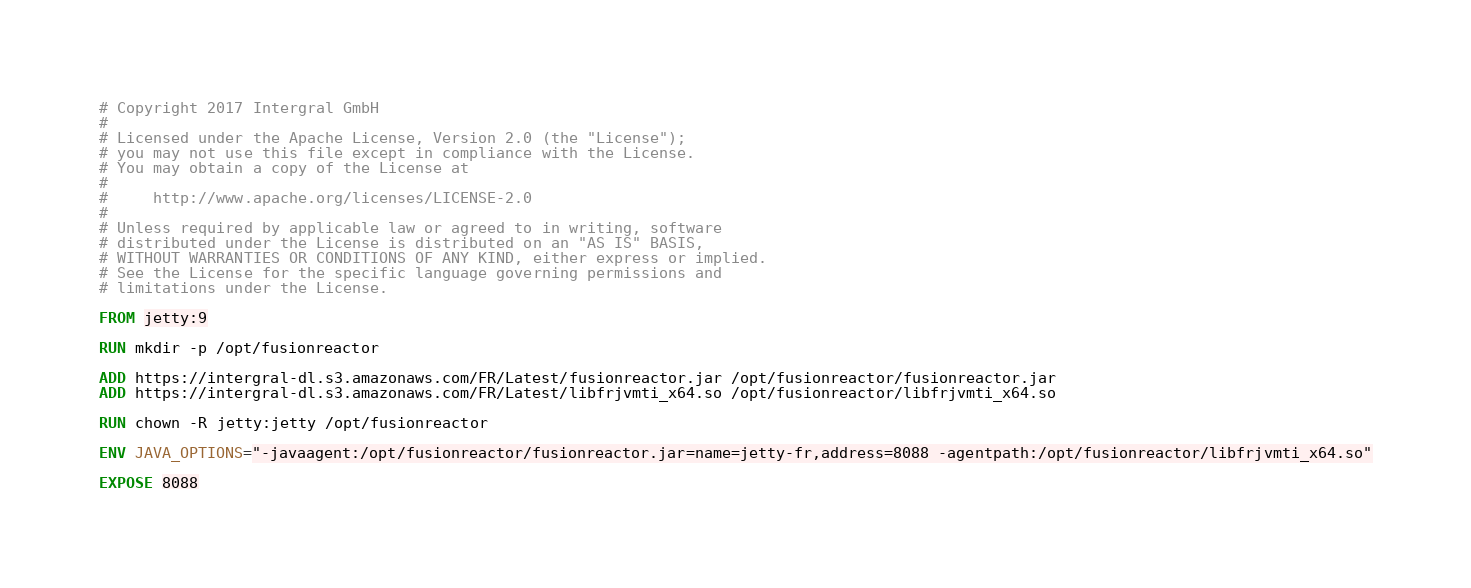<code> <loc_0><loc_0><loc_500><loc_500><_Dockerfile_># Copyright 2017 Intergral GmbH
#
# Licensed under the Apache License, Version 2.0 (the "License");
# you may not use this file except in compliance with the License.
# You may obtain a copy of the License at
#
#     http://www.apache.org/licenses/LICENSE-2.0
#
# Unless required by applicable law or agreed to in writing, software
# distributed under the License is distributed on an "AS IS" BASIS,
# WITHOUT WARRANTIES OR CONDITIONS OF ANY KIND, either express or implied.
# See the License for the specific language governing permissions and
# limitations under the License.

FROM jetty:9

RUN mkdir -p /opt/fusionreactor

ADD https://intergral-dl.s3.amazonaws.com/FR/Latest/fusionreactor.jar /opt/fusionreactor/fusionreactor.jar
ADD https://intergral-dl.s3.amazonaws.com/FR/Latest/libfrjvmti_x64.so /opt/fusionreactor/libfrjvmti_x64.so

RUN chown -R jetty:jetty /opt/fusionreactor

ENV JAVA_OPTIONS="-javaagent:/opt/fusionreactor/fusionreactor.jar=name=jetty-fr,address=8088 -agentpath:/opt/fusionreactor/libfrjvmti_x64.so"

EXPOSE 8088
</code> 